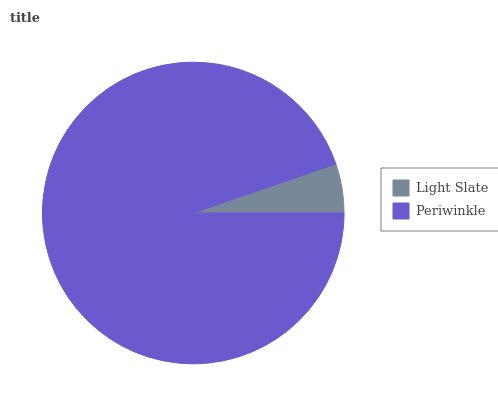Is Light Slate the minimum?
Answer yes or no. Yes. Is Periwinkle the maximum?
Answer yes or no. Yes. Is Periwinkle the minimum?
Answer yes or no. No. Is Periwinkle greater than Light Slate?
Answer yes or no. Yes. Is Light Slate less than Periwinkle?
Answer yes or no. Yes. Is Light Slate greater than Periwinkle?
Answer yes or no. No. Is Periwinkle less than Light Slate?
Answer yes or no. No. Is Periwinkle the high median?
Answer yes or no. Yes. Is Light Slate the low median?
Answer yes or no. Yes. Is Light Slate the high median?
Answer yes or no. No. Is Periwinkle the low median?
Answer yes or no. No. 